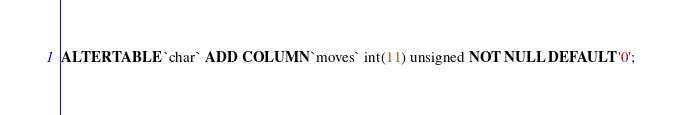<code> <loc_0><loc_0><loc_500><loc_500><_SQL_>ALTER TABLE `char` ADD COLUMN `moves` int(11) unsigned NOT NULL DEFAULT '0';</code> 